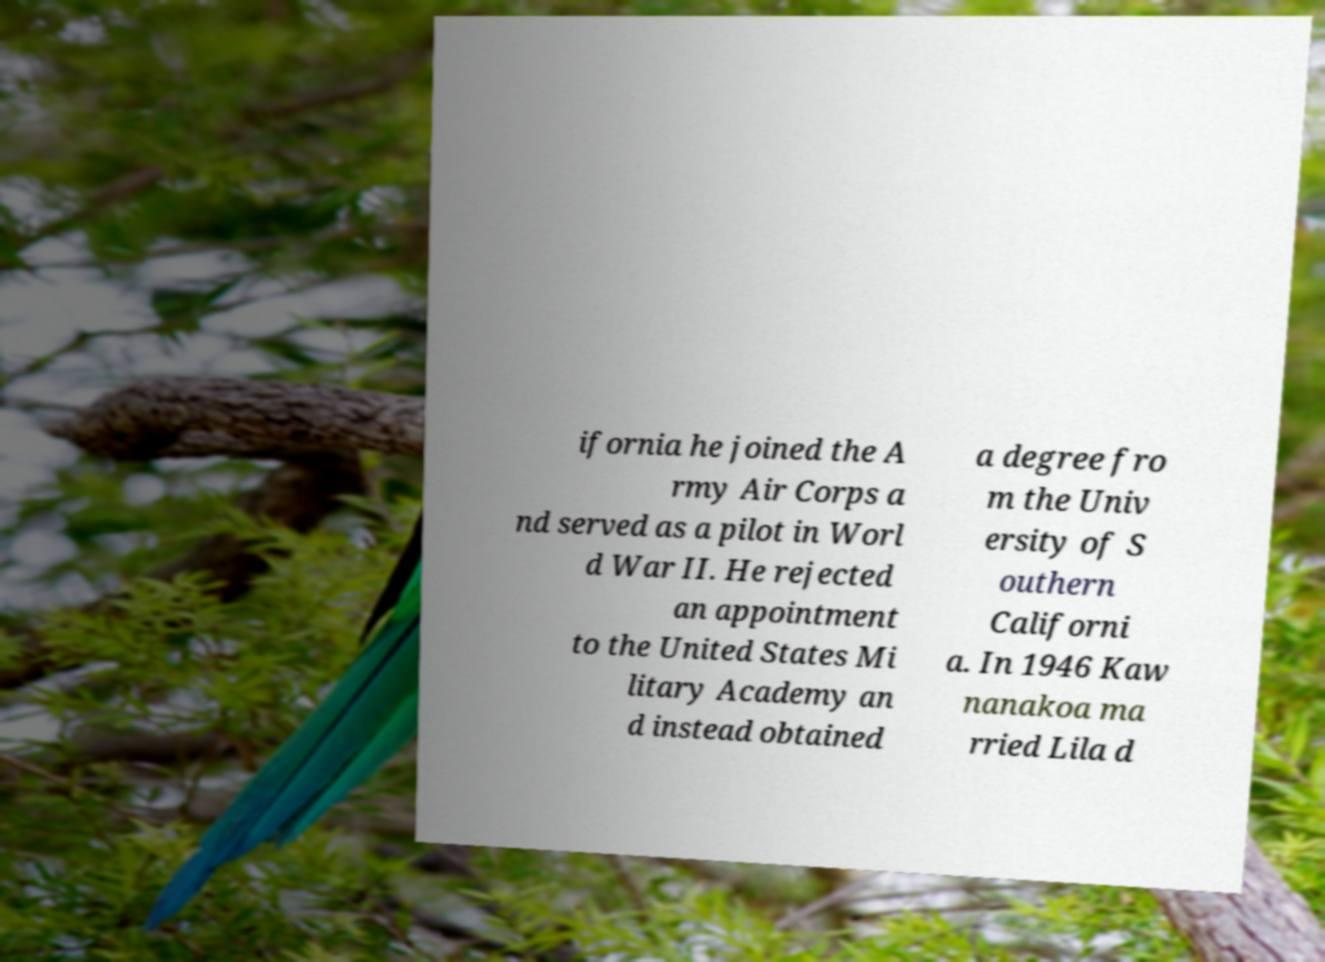Can you accurately transcribe the text from the provided image for me? ifornia he joined the A rmy Air Corps a nd served as a pilot in Worl d War II. He rejected an appointment to the United States Mi litary Academy an d instead obtained a degree fro m the Univ ersity of S outhern Californi a. In 1946 Kaw nanakoa ma rried Lila d 